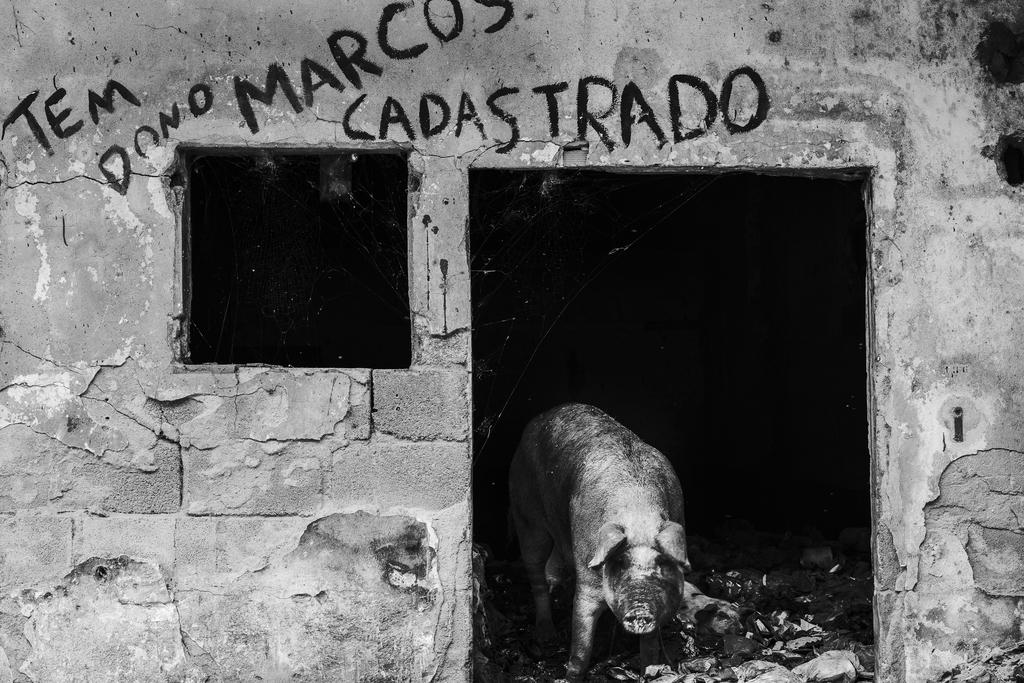What is the color scheme of the image? The image is black and white. What animal can be seen at the bottom of the image? There is a pig at the bottom of the image. What is present at the top of the image? There is something written at the top of the image. What type of carriage is being pulled by the pig in the image? There is no carriage present in the image; it only features a pig and something written at the top. Can you describe the bed that the pig is lying on in the image? There is no bed present in the image; the pig is at the bottom of the image, and there is nothing to suggest it is lying on a bed. 